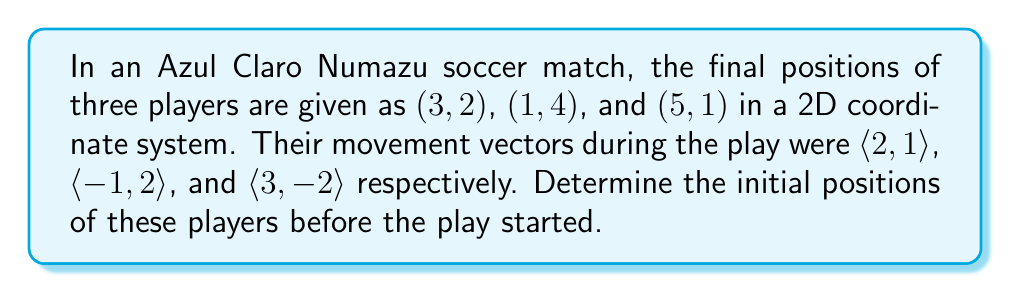Provide a solution to this math problem. To solve this inverse problem, we need to subtract the movement vectors from the final positions to obtain the initial positions. Let's do this step-by-step for each player:

1. For the player at $(3,2)$ with movement vector $\langle 2,1 \rangle$:
   Initial x-coordinate: $3 - 2 = 1$
   Initial y-coordinate: $2 - 1 = 1$
   Initial position: $(1,1)$

2. For the player at $(1,4)$ with movement vector $\langle -1,2 \rangle$:
   Initial x-coordinate: $1 - (-1) = 2$
   Initial y-coordinate: $4 - 2 = 2$
   Initial position: $(2,2)$

3. For the player at $(5,1)$ with movement vector $\langle 3,-2 \rangle$:
   Initial x-coordinate: $5 - 3 = 2$
   Initial y-coordinate: $1 - (-2) = 3$
   Initial position: $(2,3)$

Therefore, the initial positions of the three players were $(1,1)$, $(2,2)$, and $(2,3)$.
Answer: $$(1,1), (2,2), (2,3)$$ 